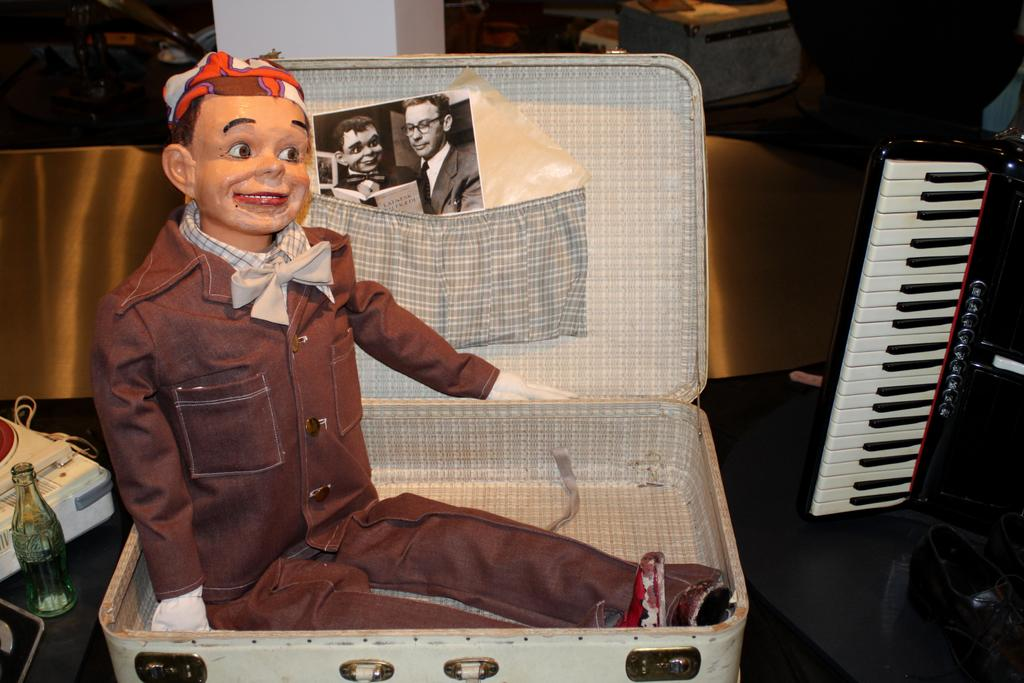What is the person in the image doing with the suitcase? The person is sitting on a suitcase. How is the person dressed in the image? The person is wearing a coat and tie. What expression does the person have in the image? The person is smiling. What can be seen in the background of the image? There is a cool drink bottle, a pillar, bags, and a musical keyboard in the background. What type of vase is placed on the musical keyboard in the image? There is no vase present on the musical keyboard in the image. 